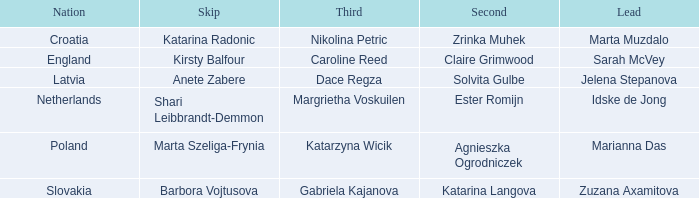Which skip has Zrinka Muhek as Second? Katarina Radonic. 